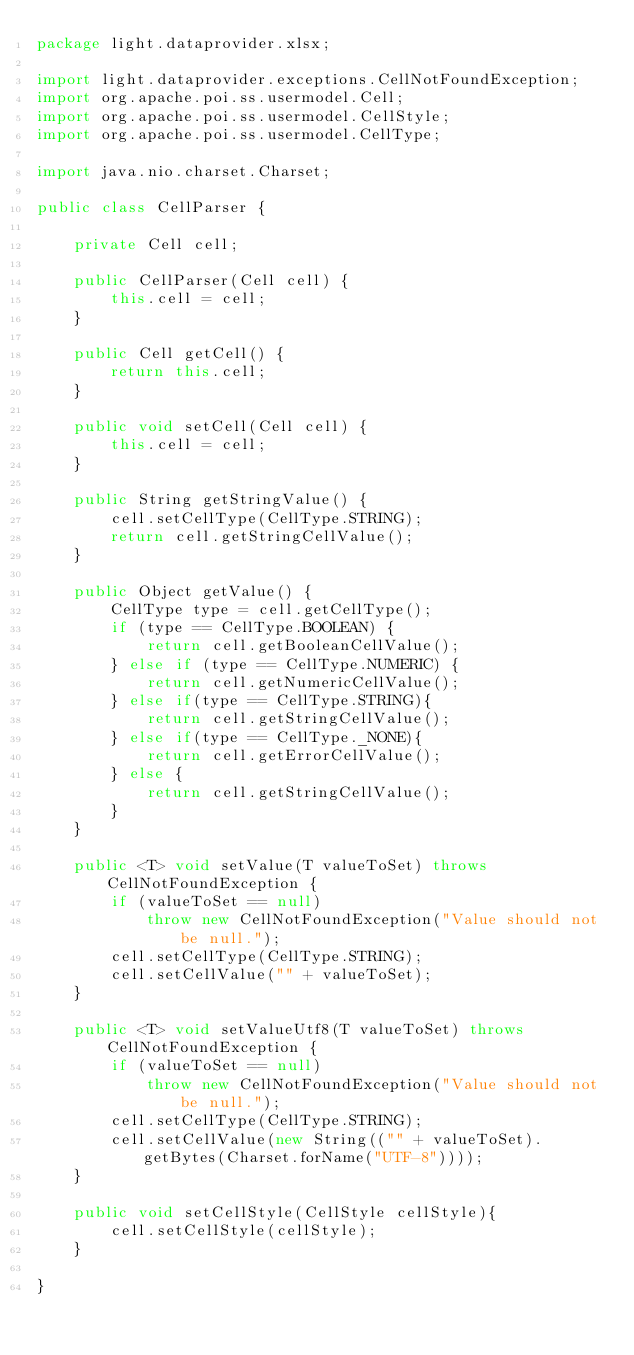Convert code to text. <code><loc_0><loc_0><loc_500><loc_500><_Java_>package light.dataprovider.xlsx;

import light.dataprovider.exceptions.CellNotFoundException;
import org.apache.poi.ss.usermodel.Cell;
import org.apache.poi.ss.usermodel.CellStyle;
import org.apache.poi.ss.usermodel.CellType;

import java.nio.charset.Charset;

public class CellParser {

    private Cell cell;

    public CellParser(Cell cell) {
        this.cell = cell;
    }

    public Cell getCell() {
        return this.cell;
    }

    public void setCell(Cell cell) {
        this.cell = cell;
    }

    public String getStringValue() {
        cell.setCellType(CellType.STRING);
        return cell.getStringCellValue();
    }

    public Object getValue() {
        CellType type = cell.getCellType();
        if (type == CellType.BOOLEAN) {
            return cell.getBooleanCellValue();
        } else if (type == CellType.NUMERIC) {
            return cell.getNumericCellValue();
        } else if(type == CellType.STRING){
            return cell.getStringCellValue();
        } else if(type == CellType._NONE){
            return cell.getErrorCellValue();
        } else {
            return cell.getStringCellValue();
        }
    }

    public <T> void setValue(T valueToSet) throws CellNotFoundException {
        if (valueToSet == null)
            throw new CellNotFoundException("Value should not be null.");
        cell.setCellType(CellType.STRING);
        cell.setCellValue("" + valueToSet);
    }

    public <T> void setValueUtf8(T valueToSet) throws CellNotFoundException {
        if (valueToSet == null)
            throw new CellNotFoundException("Value should not be null.");
        cell.setCellType(CellType.STRING);
        cell.setCellValue(new String(("" + valueToSet).getBytes(Charset.forName("UTF-8"))));
    }

    public void setCellStyle(CellStyle cellStyle){
        cell.setCellStyle(cellStyle);
    }

}
</code> 